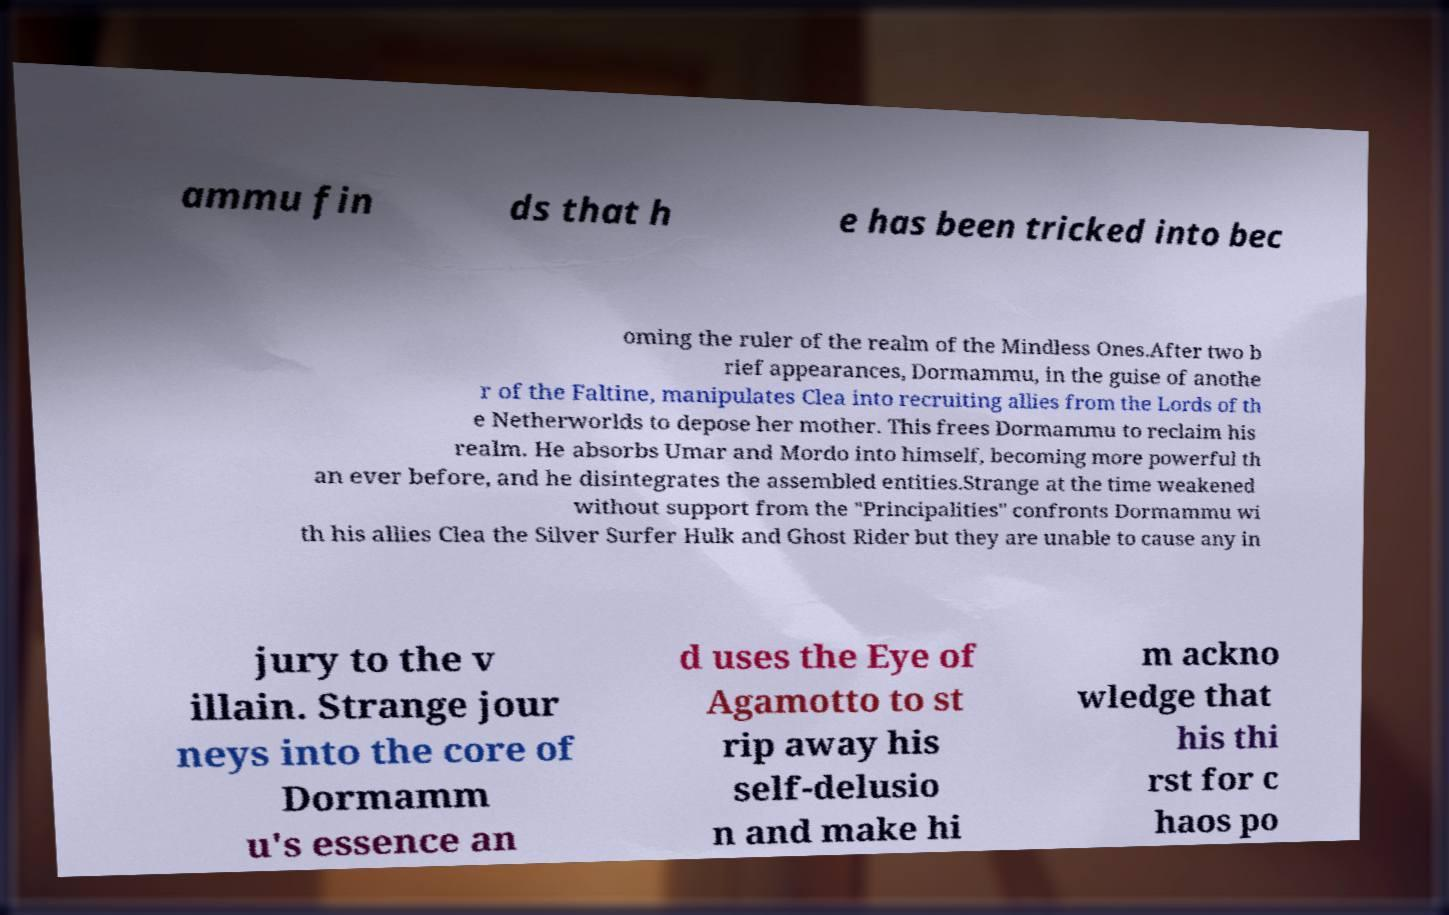Could you assist in decoding the text presented in this image and type it out clearly? ammu fin ds that h e has been tricked into bec oming the ruler of the realm of the Mindless Ones.After two b rief appearances, Dormammu, in the guise of anothe r of the Faltine, manipulates Clea into recruiting allies from the Lords of th e Netherworlds to depose her mother. This frees Dormammu to reclaim his realm. He absorbs Umar and Mordo into himself, becoming more powerful th an ever before, and he disintegrates the assembled entities.Strange at the time weakened without support from the "Principalities" confronts Dormammu wi th his allies Clea the Silver Surfer Hulk and Ghost Rider but they are unable to cause any in jury to the v illain. Strange jour neys into the core of Dormamm u's essence an d uses the Eye of Agamotto to st rip away his self-delusio n and make hi m ackno wledge that his thi rst for c haos po 